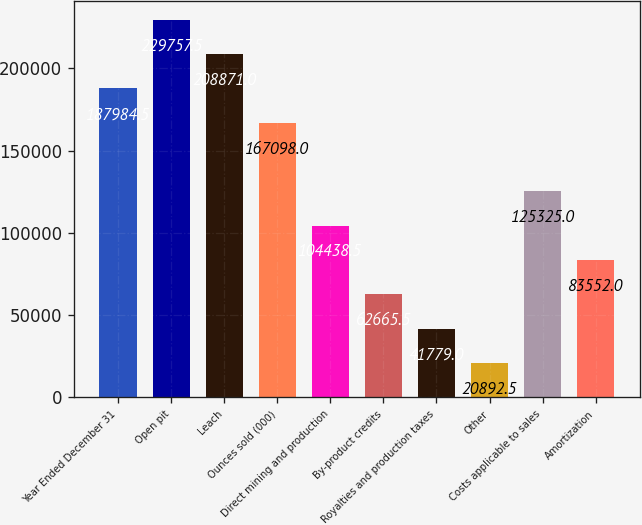<chart> <loc_0><loc_0><loc_500><loc_500><bar_chart><fcel>Year Ended December 31<fcel>Open pit<fcel>Leach<fcel>Ounces sold (000)<fcel>Direct mining and production<fcel>By-product credits<fcel>Royalties and production taxes<fcel>Other<fcel>Costs applicable to sales<fcel>Amortization<nl><fcel>187984<fcel>229758<fcel>208871<fcel>167098<fcel>104438<fcel>62665.5<fcel>41779<fcel>20892.5<fcel>125325<fcel>83552<nl></chart> 